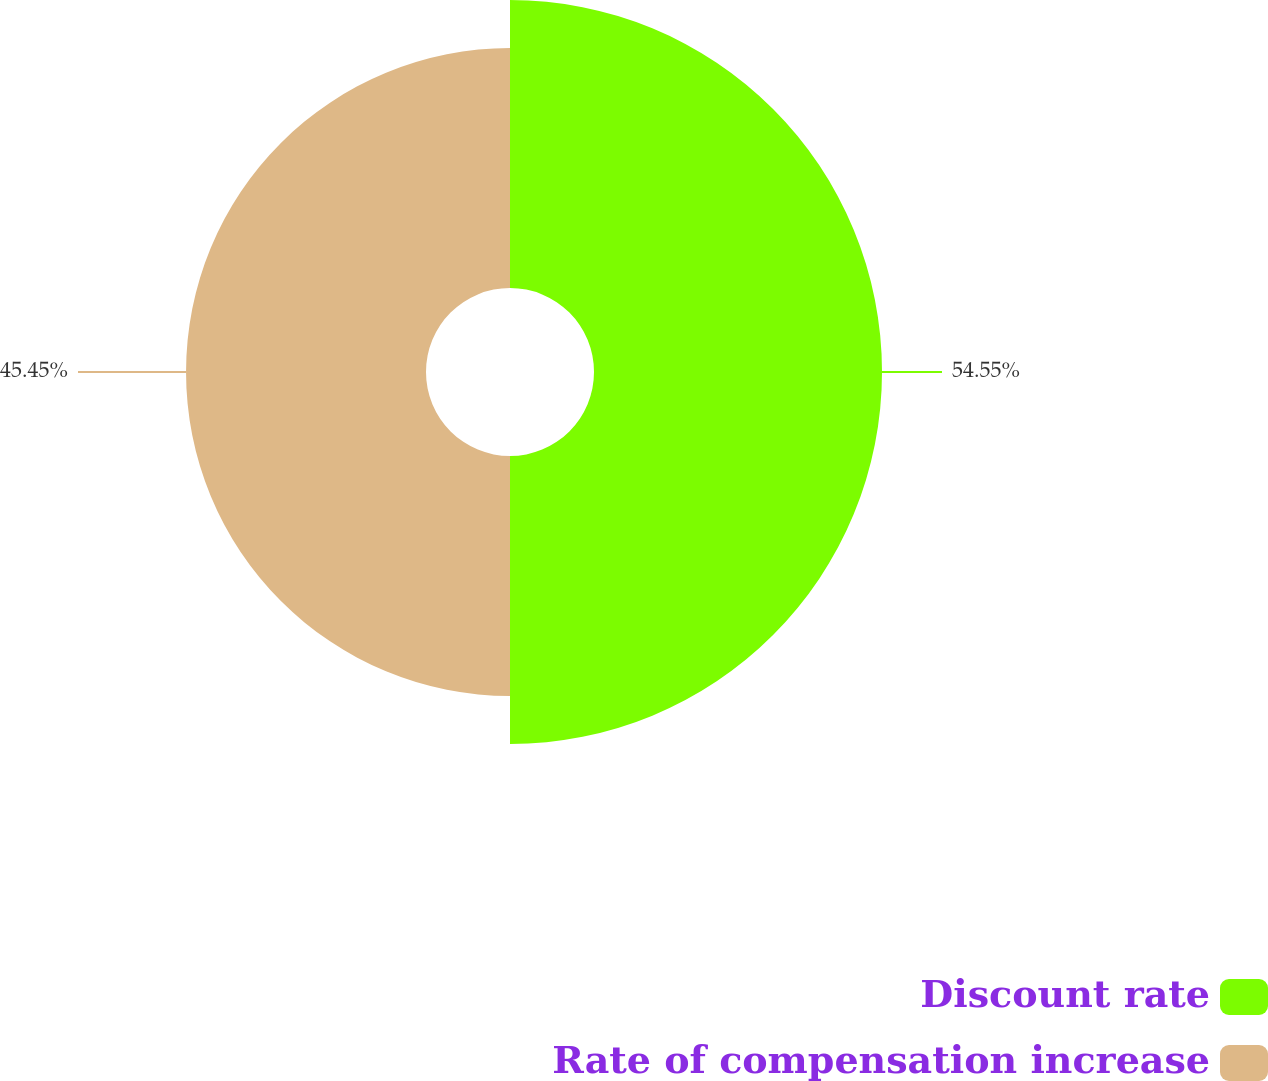Convert chart to OTSL. <chart><loc_0><loc_0><loc_500><loc_500><pie_chart><fcel>Discount rate<fcel>Rate of compensation increase<nl><fcel>54.55%<fcel>45.45%<nl></chart> 